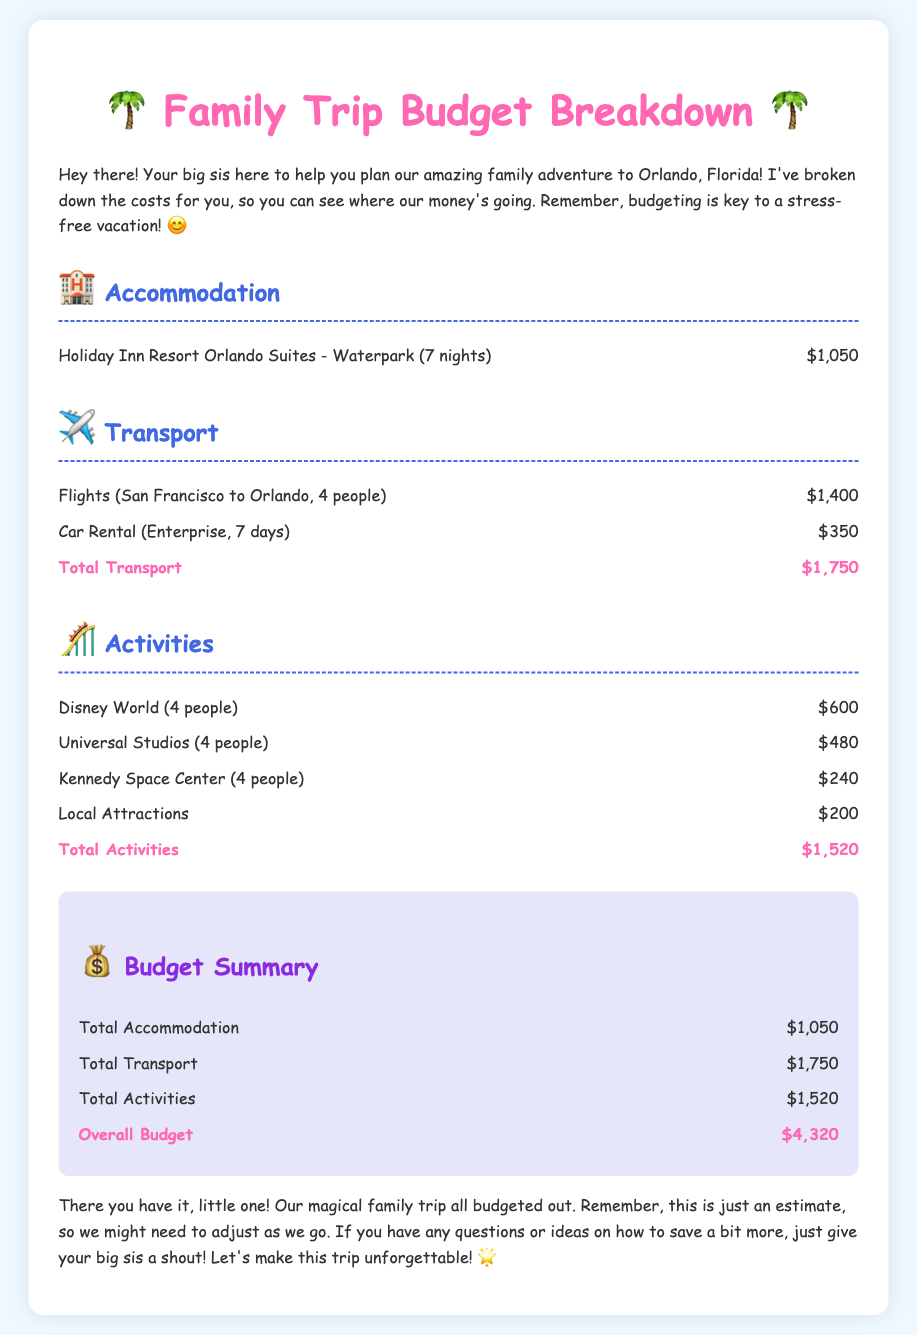What is the total cost for accommodation? The total cost for accommodation is found in the Accommodation section, which lists the Holiday Inn Resort for 7 nights at $1,050.
Answer: $1,050 How much do the flights cost? The cost of flights from San Francisco to Orlando for 4 people is specifically mentioned under the Transport section as $1,400.
Answer: $1,400 What is the total cost for activities? The total for activities is provided in the Activities section, which sums up each attraction's cost to $1,520.
Answer: $1,520 How much is the car rental? The car rental cost, as listed in the Transport section, is explicitly mentioned as $350 for 7 days.
Answer: $350 What is the total overall budget for the trip? The overall budget is the sum of accommodation, transport, and activities in the Budget Summary section, which totals $4,320.
Answer: $4,320 What activity costs the least? The document includes costs for various activities, with the Kennedy Space Center at $240 being the lowest.
Answer: $240 How many nights will we stay at the hotel? The accommodation section states that we will be staying at the hotel for 7 nights.
Answer: 7 nights What is the cost for Universal Studios? The cost listed under Activities for Universal Studios for 4 people is $480.
Answer: $480 How many people are included in the flights cost? The flights cost covers 4 people, as specified in the Transport section.
Answer: 4 people 